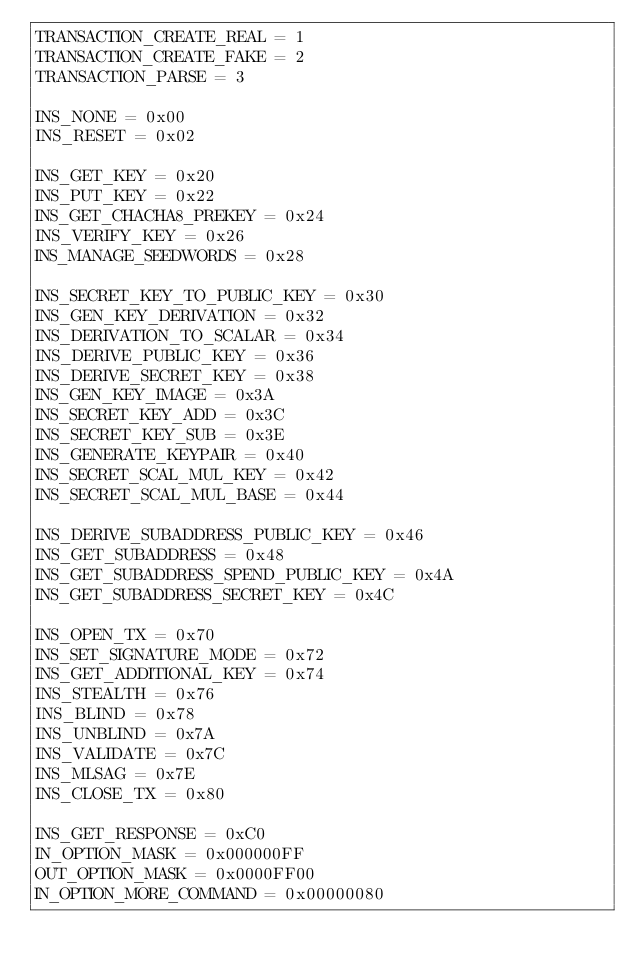Convert code to text. <code><loc_0><loc_0><loc_500><loc_500><_Python_>TRANSACTION_CREATE_REAL = 1
TRANSACTION_CREATE_FAKE = 2
TRANSACTION_PARSE = 3

INS_NONE = 0x00
INS_RESET = 0x02

INS_GET_KEY = 0x20
INS_PUT_KEY = 0x22
INS_GET_CHACHA8_PREKEY = 0x24
INS_VERIFY_KEY = 0x26
INS_MANAGE_SEEDWORDS = 0x28

INS_SECRET_KEY_TO_PUBLIC_KEY = 0x30
INS_GEN_KEY_DERIVATION = 0x32
INS_DERIVATION_TO_SCALAR = 0x34
INS_DERIVE_PUBLIC_KEY = 0x36
INS_DERIVE_SECRET_KEY = 0x38
INS_GEN_KEY_IMAGE = 0x3A
INS_SECRET_KEY_ADD = 0x3C
INS_SECRET_KEY_SUB = 0x3E
INS_GENERATE_KEYPAIR = 0x40
INS_SECRET_SCAL_MUL_KEY = 0x42
INS_SECRET_SCAL_MUL_BASE = 0x44

INS_DERIVE_SUBADDRESS_PUBLIC_KEY = 0x46
INS_GET_SUBADDRESS = 0x48
INS_GET_SUBADDRESS_SPEND_PUBLIC_KEY = 0x4A
INS_GET_SUBADDRESS_SECRET_KEY = 0x4C

INS_OPEN_TX = 0x70
INS_SET_SIGNATURE_MODE = 0x72
INS_GET_ADDITIONAL_KEY = 0x74
INS_STEALTH = 0x76
INS_BLIND = 0x78
INS_UNBLIND = 0x7A
INS_VALIDATE = 0x7C
INS_MLSAG = 0x7E
INS_CLOSE_TX = 0x80

INS_GET_RESPONSE = 0xC0
IN_OPTION_MASK = 0x000000FF
OUT_OPTION_MASK = 0x0000FF00
IN_OPTION_MORE_COMMAND = 0x00000080

</code> 